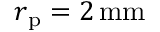<formula> <loc_0><loc_0><loc_500><loc_500>r _ { p } = 2 \, m m</formula> 